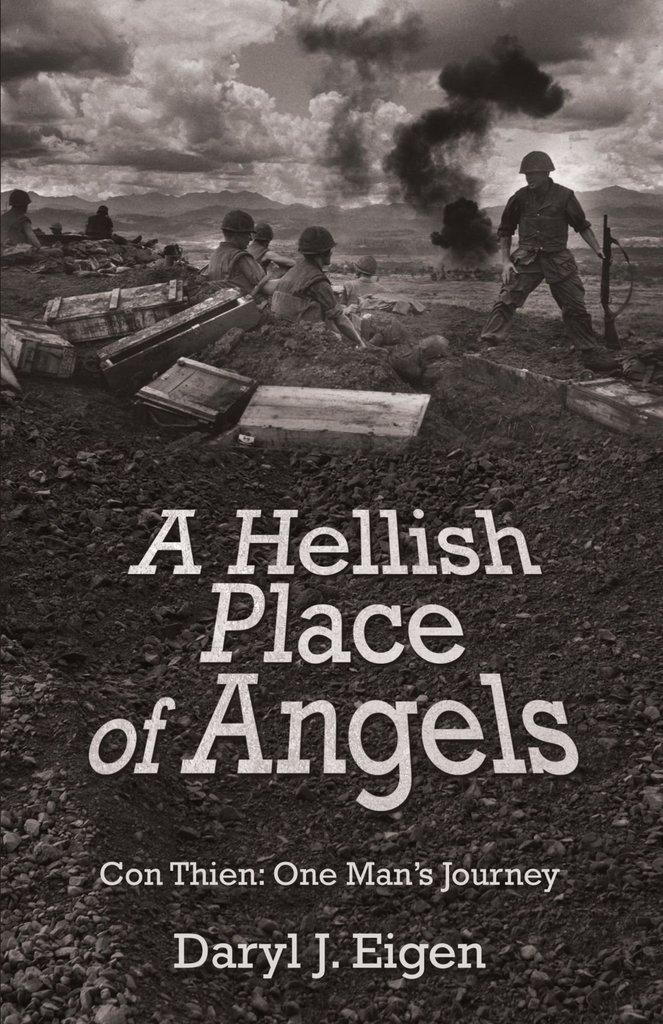<image>
Share a concise interpretation of the image provided. Daryl Eigen's book, A Hellish Place of Angels, bears a grim war scene on the cover. 